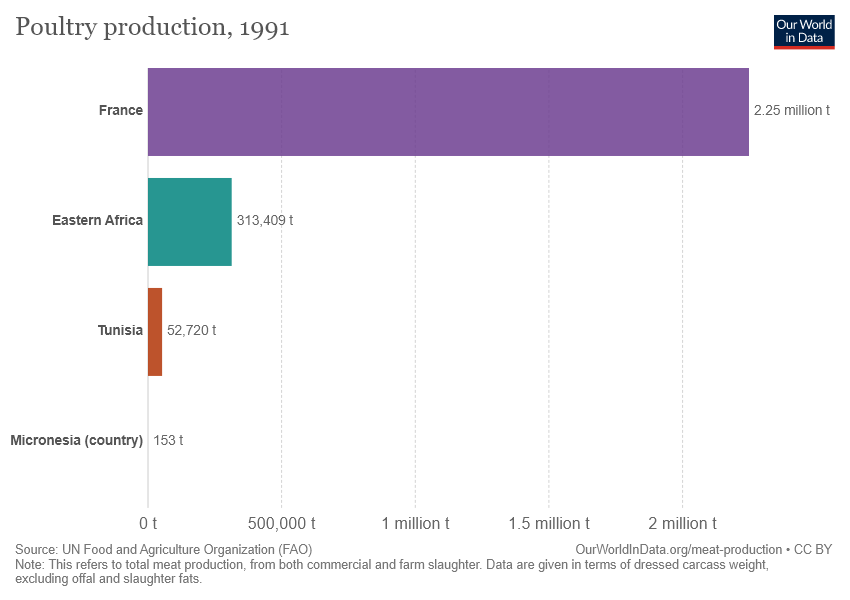Indicate a few pertinent items in this graphic. The poultry production value in Eastern Africa is greater than in Tunisia. The poultry production in France is 2.25. 